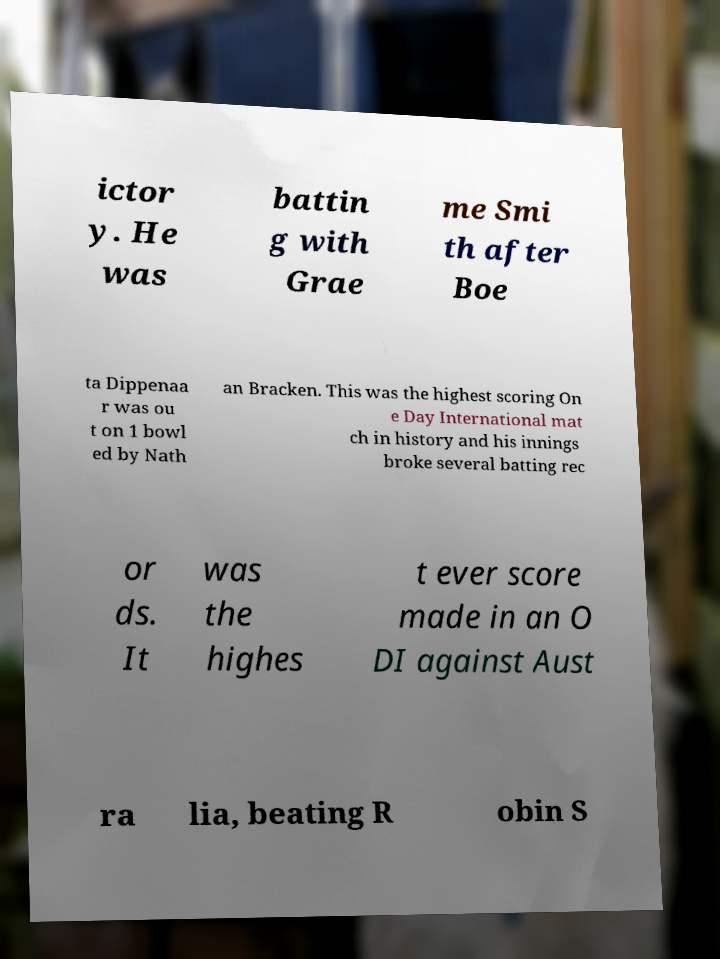Can you accurately transcribe the text from the provided image for me? ictor y. He was battin g with Grae me Smi th after Boe ta Dippenaa r was ou t on 1 bowl ed by Nath an Bracken. This was the highest scoring On e Day International mat ch in history and his innings broke several batting rec or ds. It was the highes t ever score made in an O DI against Aust ra lia, beating R obin S 